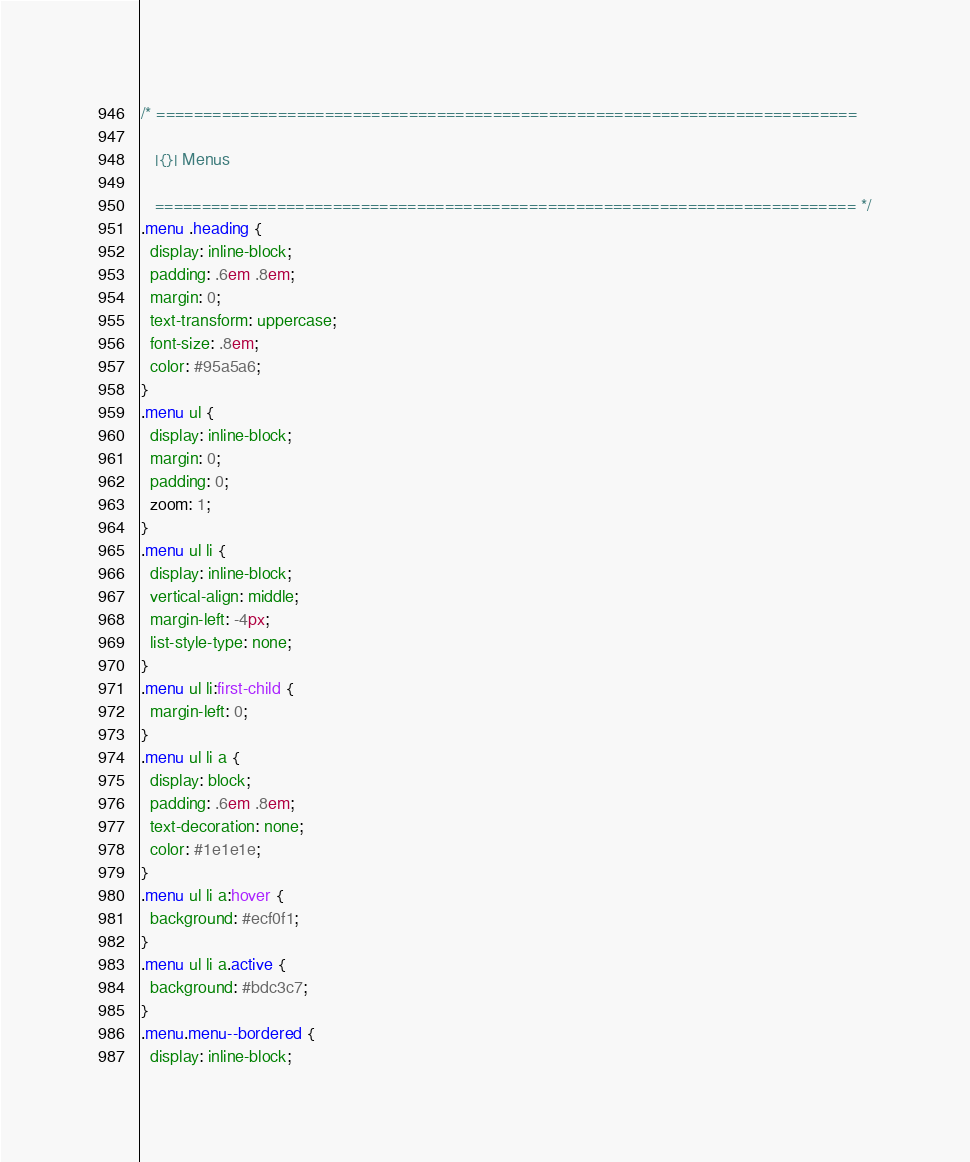Convert code to text. <code><loc_0><loc_0><loc_500><loc_500><_CSS_>/* ===========================================================================

   |{}| Menus
   
   =========================================================================== */
.menu .heading {
  display: inline-block;
  padding: .6em .8em;
  margin: 0;
  text-transform: uppercase;
  font-size: .8em;
  color: #95a5a6;
}
.menu ul {
  display: inline-block;
  margin: 0;
  padding: 0;
  zoom: 1;
}
.menu ul li {
  display: inline-block;
  vertical-align: middle;
  margin-left: -4px;
  list-style-type: none;
}
.menu ul li:first-child {
  margin-left: 0;
}
.menu ul li a {
  display: block;
  padding: .6em .8em;
  text-decoration: none;
  color: #1e1e1e;
}
.menu ul li a:hover {
  background: #ecf0f1;
}
.menu ul li a.active {
  background: #bdc3c7;
}
.menu.menu--bordered {
  display: inline-block;</code> 